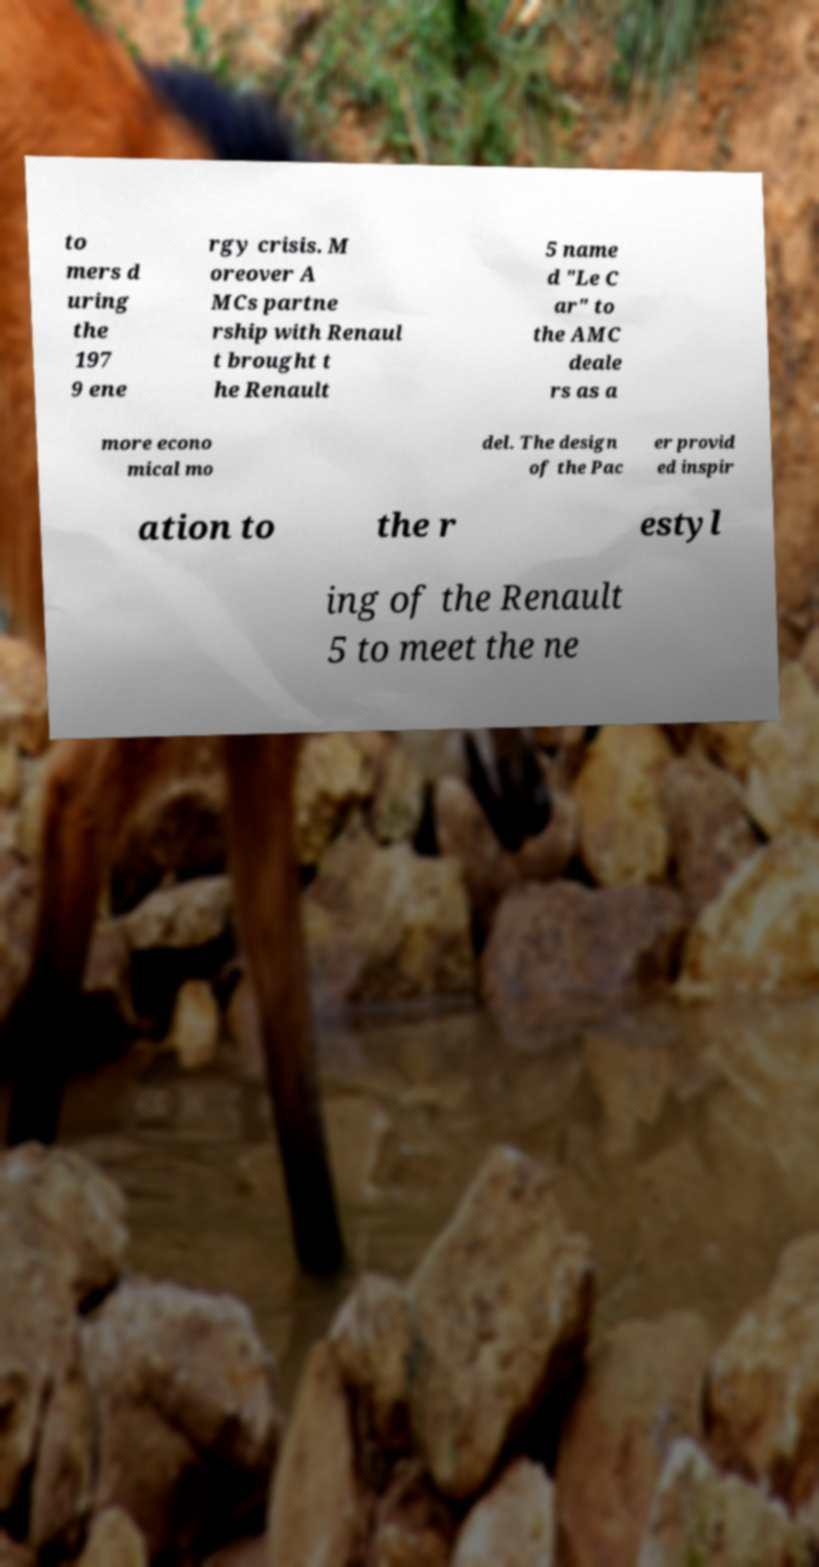I need the written content from this picture converted into text. Can you do that? to mers d uring the 197 9 ene rgy crisis. M oreover A MCs partne rship with Renaul t brought t he Renault 5 name d "Le C ar" to the AMC deale rs as a more econo mical mo del. The design of the Pac er provid ed inspir ation to the r estyl ing of the Renault 5 to meet the ne 